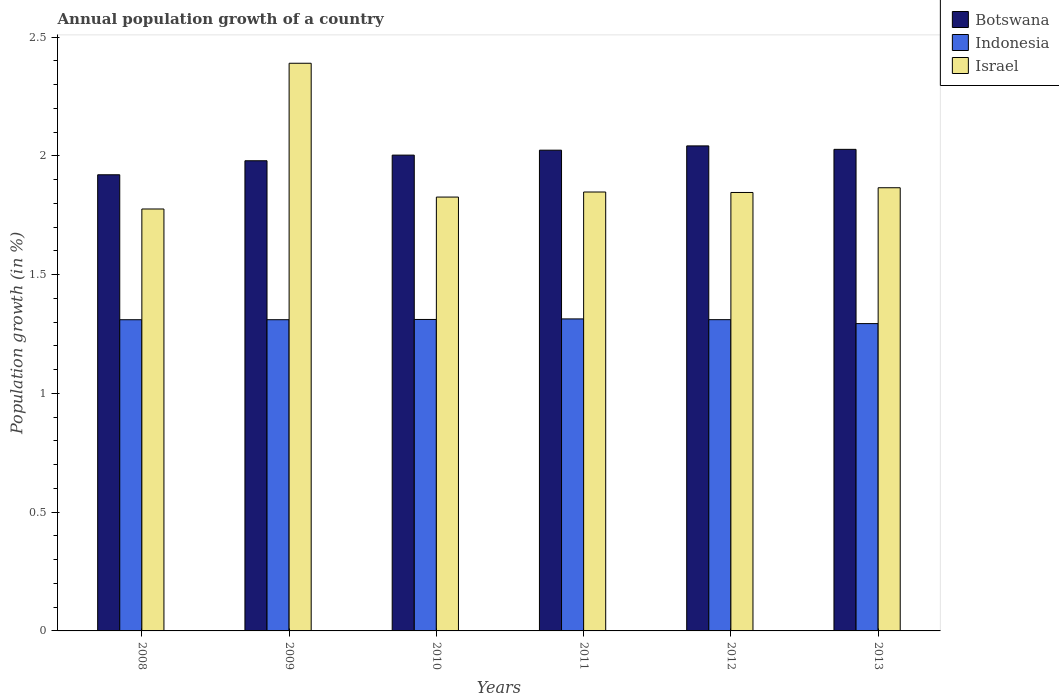How many groups of bars are there?
Your response must be concise. 6. Are the number of bars on each tick of the X-axis equal?
Ensure brevity in your answer.  Yes. How many bars are there on the 4th tick from the right?
Provide a succinct answer. 3. What is the label of the 2nd group of bars from the left?
Offer a terse response. 2009. In how many cases, is the number of bars for a given year not equal to the number of legend labels?
Keep it short and to the point. 0. What is the annual population growth in Israel in 2010?
Offer a very short reply. 1.83. Across all years, what is the maximum annual population growth in Indonesia?
Offer a very short reply. 1.31. Across all years, what is the minimum annual population growth in Israel?
Keep it short and to the point. 1.78. In which year was the annual population growth in Botswana maximum?
Provide a short and direct response. 2012. In which year was the annual population growth in Botswana minimum?
Your answer should be very brief. 2008. What is the total annual population growth in Indonesia in the graph?
Make the answer very short. 7.85. What is the difference between the annual population growth in Indonesia in 2009 and that in 2011?
Your answer should be very brief. -0. What is the difference between the annual population growth in Botswana in 2011 and the annual population growth in Indonesia in 2009?
Give a very brief answer. 0.71. What is the average annual population growth in Israel per year?
Give a very brief answer. 1.93. In the year 2013, what is the difference between the annual population growth in Botswana and annual population growth in Israel?
Provide a succinct answer. 0.16. In how many years, is the annual population growth in Botswana greater than 1.9 %?
Your answer should be very brief. 6. What is the ratio of the annual population growth in Indonesia in 2008 to that in 2012?
Provide a short and direct response. 1. Is the annual population growth in Israel in 2009 less than that in 2013?
Offer a terse response. No. Is the difference between the annual population growth in Botswana in 2008 and 2012 greater than the difference between the annual population growth in Israel in 2008 and 2012?
Give a very brief answer. No. What is the difference between the highest and the second highest annual population growth in Botswana?
Your response must be concise. 0.01. What is the difference between the highest and the lowest annual population growth in Israel?
Provide a succinct answer. 0.61. What does the 2nd bar from the left in 2010 represents?
Provide a succinct answer. Indonesia. What does the 2nd bar from the right in 2010 represents?
Your response must be concise. Indonesia. How many bars are there?
Your response must be concise. 18. Are all the bars in the graph horizontal?
Keep it short and to the point. No. How many years are there in the graph?
Provide a succinct answer. 6. Where does the legend appear in the graph?
Your answer should be compact. Top right. How many legend labels are there?
Your answer should be very brief. 3. What is the title of the graph?
Keep it short and to the point. Annual population growth of a country. Does "Moldova" appear as one of the legend labels in the graph?
Provide a succinct answer. No. What is the label or title of the X-axis?
Provide a short and direct response. Years. What is the label or title of the Y-axis?
Make the answer very short. Population growth (in %). What is the Population growth (in %) of Botswana in 2008?
Provide a short and direct response. 1.92. What is the Population growth (in %) in Indonesia in 2008?
Offer a very short reply. 1.31. What is the Population growth (in %) of Israel in 2008?
Give a very brief answer. 1.78. What is the Population growth (in %) in Botswana in 2009?
Your answer should be very brief. 1.98. What is the Population growth (in %) in Indonesia in 2009?
Provide a short and direct response. 1.31. What is the Population growth (in %) of Israel in 2009?
Make the answer very short. 2.39. What is the Population growth (in %) of Botswana in 2010?
Make the answer very short. 2. What is the Population growth (in %) of Indonesia in 2010?
Ensure brevity in your answer.  1.31. What is the Population growth (in %) of Israel in 2010?
Give a very brief answer. 1.83. What is the Population growth (in %) in Botswana in 2011?
Provide a short and direct response. 2.02. What is the Population growth (in %) of Indonesia in 2011?
Your answer should be very brief. 1.31. What is the Population growth (in %) in Israel in 2011?
Your answer should be very brief. 1.85. What is the Population growth (in %) in Botswana in 2012?
Offer a terse response. 2.04. What is the Population growth (in %) in Indonesia in 2012?
Keep it short and to the point. 1.31. What is the Population growth (in %) in Israel in 2012?
Ensure brevity in your answer.  1.85. What is the Population growth (in %) in Botswana in 2013?
Offer a very short reply. 2.03. What is the Population growth (in %) of Indonesia in 2013?
Keep it short and to the point. 1.29. What is the Population growth (in %) of Israel in 2013?
Offer a terse response. 1.87. Across all years, what is the maximum Population growth (in %) of Botswana?
Give a very brief answer. 2.04. Across all years, what is the maximum Population growth (in %) of Indonesia?
Your response must be concise. 1.31. Across all years, what is the maximum Population growth (in %) in Israel?
Give a very brief answer. 2.39. Across all years, what is the minimum Population growth (in %) of Botswana?
Your answer should be very brief. 1.92. Across all years, what is the minimum Population growth (in %) in Indonesia?
Your answer should be compact. 1.29. Across all years, what is the minimum Population growth (in %) of Israel?
Your response must be concise. 1.78. What is the total Population growth (in %) in Botswana in the graph?
Offer a terse response. 12. What is the total Population growth (in %) in Indonesia in the graph?
Your response must be concise. 7.85. What is the total Population growth (in %) of Israel in the graph?
Provide a short and direct response. 11.55. What is the difference between the Population growth (in %) in Botswana in 2008 and that in 2009?
Ensure brevity in your answer.  -0.06. What is the difference between the Population growth (in %) of Israel in 2008 and that in 2009?
Ensure brevity in your answer.  -0.61. What is the difference between the Population growth (in %) of Botswana in 2008 and that in 2010?
Your answer should be very brief. -0.08. What is the difference between the Population growth (in %) in Indonesia in 2008 and that in 2010?
Offer a terse response. -0. What is the difference between the Population growth (in %) in Israel in 2008 and that in 2010?
Your answer should be very brief. -0.05. What is the difference between the Population growth (in %) of Botswana in 2008 and that in 2011?
Your response must be concise. -0.1. What is the difference between the Population growth (in %) of Indonesia in 2008 and that in 2011?
Ensure brevity in your answer.  -0. What is the difference between the Population growth (in %) in Israel in 2008 and that in 2011?
Make the answer very short. -0.07. What is the difference between the Population growth (in %) of Botswana in 2008 and that in 2012?
Offer a terse response. -0.12. What is the difference between the Population growth (in %) in Indonesia in 2008 and that in 2012?
Ensure brevity in your answer.  -0. What is the difference between the Population growth (in %) in Israel in 2008 and that in 2012?
Keep it short and to the point. -0.07. What is the difference between the Population growth (in %) in Botswana in 2008 and that in 2013?
Provide a short and direct response. -0.11. What is the difference between the Population growth (in %) of Indonesia in 2008 and that in 2013?
Offer a terse response. 0.02. What is the difference between the Population growth (in %) in Israel in 2008 and that in 2013?
Make the answer very short. -0.09. What is the difference between the Population growth (in %) of Botswana in 2009 and that in 2010?
Provide a short and direct response. -0.02. What is the difference between the Population growth (in %) in Indonesia in 2009 and that in 2010?
Provide a succinct answer. -0. What is the difference between the Population growth (in %) in Israel in 2009 and that in 2010?
Keep it short and to the point. 0.56. What is the difference between the Population growth (in %) in Botswana in 2009 and that in 2011?
Provide a succinct answer. -0.04. What is the difference between the Population growth (in %) of Indonesia in 2009 and that in 2011?
Ensure brevity in your answer.  -0. What is the difference between the Population growth (in %) in Israel in 2009 and that in 2011?
Provide a succinct answer. 0.54. What is the difference between the Population growth (in %) of Botswana in 2009 and that in 2012?
Make the answer very short. -0.06. What is the difference between the Population growth (in %) in Indonesia in 2009 and that in 2012?
Your answer should be very brief. -0. What is the difference between the Population growth (in %) in Israel in 2009 and that in 2012?
Your answer should be very brief. 0.54. What is the difference between the Population growth (in %) of Botswana in 2009 and that in 2013?
Keep it short and to the point. -0.05. What is the difference between the Population growth (in %) of Indonesia in 2009 and that in 2013?
Provide a succinct answer. 0.02. What is the difference between the Population growth (in %) in Israel in 2009 and that in 2013?
Your response must be concise. 0.52. What is the difference between the Population growth (in %) in Botswana in 2010 and that in 2011?
Offer a very short reply. -0.02. What is the difference between the Population growth (in %) in Indonesia in 2010 and that in 2011?
Your response must be concise. -0. What is the difference between the Population growth (in %) in Israel in 2010 and that in 2011?
Make the answer very short. -0.02. What is the difference between the Population growth (in %) in Botswana in 2010 and that in 2012?
Offer a terse response. -0.04. What is the difference between the Population growth (in %) in Indonesia in 2010 and that in 2012?
Your answer should be very brief. 0. What is the difference between the Population growth (in %) in Israel in 2010 and that in 2012?
Your answer should be compact. -0.02. What is the difference between the Population growth (in %) in Botswana in 2010 and that in 2013?
Your answer should be very brief. -0.02. What is the difference between the Population growth (in %) in Indonesia in 2010 and that in 2013?
Provide a short and direct response. 0.02. What is the difference between the Population growth (in %) of Israel in 2010 and that in 2013?
Your answer should be very brief. -0.04. What is the difference between the Population growth (in %) of Botswana in 2011 and that in 2012?
Offer a terse response. -0.02. What is the difference between the Population growth (in %) in Indonesia in 2011 and that in 2012?
Make the answer very short. 0. What is the difference between the Population growth (in %) in Israel in 2011 and that in 2012?
Your answer should be very brief. 0. What is the difference between the Population growth (in %) in Botswana in 2011 and that in 2013?
Provide a short and direct response. -0. What is the difference between the Population growth (in %) of Indonesia in 2011 and that in 2013?
Give a very brief answer. 0.02. What is the difference between the Population growth (in %) of Israel in 2011 and that in 2013?
Offer a terse response. -0.02. What is the difference between the Population growth (in %) in Botswana in 2012 and that in 2013?
Your answer should be very brief. 0.01. What is the difference between the Population growth (in %) of Indonesia in 2012 and that in 2013?
Provide a short and direct response. 0.02. What is the difference between the Population growth (in %) of Israel in 2012 and that in 2013?
Ensure brevity in your answer.  -0.02. What is the difference between the Population growth (in %) of Botswana in 2008 and the Population growth (in %) of Indonesia in 2009?
Ensure brevity in your answer.  0.61. What is the difference between the Population growth (in %) of Botswana in 2008 and the Population growth (in %) of Israel in 2009?
Provide a short and direct response. -0.47. What is the difference between the Population growth (in %) of Indonesia in 2008 and the Population growth (in %) of Israel in 2009?
Your answer should be compact. -1.08. What is the difference between the Population growth (in %) in Botswana in 2008 and the Population growth (in %) in Indonesia in 2010?
Your response must be concise. 0.61. What is the difference between the Population growth (in %) in Botswana in 2008 and the Population growth (in %) in Israel in 2010?
Provide a succinct answer. 0.09. What is the difference between the Population growth (in %) of Indonesia in 2008 and the Population growth (in %) of Israel in 2010?
Your answer should be very brief. -0.52. What is the difference between the Population growth (in %) of Botswana in 2008 and the Population growth (in %) of Indonesia in 2011?
Keep it short and to the point. 0.61. What is the difference between the Population growth (in %) of Botswana in 2008 and the Population growth (in %) of Israel in 2011?
Offer a very short reply. 0.07. What is the difference between the Population growth (in %) of Indonesia in 2008 and the Population growth (in %) of Israel in 2011?
Your answer should be compact. -0.54. What is the difference between the Population growth (in %) of Botswana in 2008 and the Population growth (in %) of Indonesia in 2012?
Your answer should be compact. 0.61. What is the difference between the Population growth (in %) in Botswana in 2008 and the Population growth (in %) in Israel in 2012?
Offer a terse response. 0.07. What is the difference between the Population growth (in %) of Indonesia in 2008 and the Population growth (in %) of Israel in 2012?
Keep it short and to the point. -0.54. What is the difference between the Population growth (in %) of Botswana in 2008 and the Population growth (in %) of Indonesia in 2013?
Your response must be concise. 0.63. What is the difference between the Population growth (in %) of Botswana in 2008 and the Population growth (in %) of Israel in 2013?
Offer a terse response. 0.05. What is the difference between the Population growth (in %) of Indonesia in 2008 and the Population growth (in %) of Israel in 2013?
Your answer should be very brief. -0.56. What is the difference between the Population growth (in %) in Botswana in 2009 and the Population growth (in %) in Indonesia in 2010?
Provide a succinct answer. 0.67. What is the difference between the Population growth (in %) in Botswana in 2009 and the Population growth (in %) in Israel in 2010?
Ensure brevity in your answer.  0.15. What is the difference between the Population growth (in %) in Indonesia in 2009 and the Population growth (in %) in Israel in 2010?
Give a very brief answer. -0.52. What is the difference between the Population growth (in %) of Botswana in 2009 and the Population growth (in %) of Indonesia in 2011?
Your answer should be very brief. 0.67. What is the difference between the Population growth (in %) of Botswana in 2009 and the Population growth (in %) of Israel in 2011?
Provide a succinct answer. 0.13. What is the difference between the Population growth (in %) in Indonesia in 2009 and the Population growth (in %) in Israel in 2011?
Provide a short and direct response. -0.54. What is the difference between the Population growth (in %) of Botswana in 2009 and the Population growth (in %) of Indonesia in 2012?
Your answer should be compact. 0.67. What is the difference between the Population growth (in %) of Botswana in 2009 and the Population growth (in %) of Israel in 2012?
Your response must be concise. 0.13. What is the difference between the Population growth (in %) in Indonesia in 2009 and the Population growth (in %) in Israel in 2012?
Provide a short and direct response. -0.54. What is the difference between the Population growth (in %) of Botswana in 2009 and the Population growth (in %) of Indonesia in 2013?
Your response must be concise. 0.69. What is the difference between the Population growth (in %) in Botswana in 2009 and the Population growth (in %) in Israel in 2013?
Provide a short and direct response. 0.11. What is the difference between the Population growth (in %) in Indonesia in 2009 and the Population growth (in %) in Israel in 2013?
Your answer should be very brief. -0.56. What is the difference between the Population growth (in %) in Botswana in 2010 and the Population growth (in %) in Indonesia in 2011?
Your answer should be compact. 0.69. What is the difference between the Population growth (in %) of Botswana in 2010 and the Population growth (in %) of Israel in 2011?
Make the answer very short. 0.16. What is the difference between the Population growth (in %) in Indonesia in 2010 and the Population growth (in %) in Israel in 2011?
Provide a succinct answer. -0.54. What is the difference between the Population growth (in %) in Botswana in 2010 and the Population growth (in %) in Indonesia in 2012?
Offer a very short reply. 0.69. What is the difference between the Population growth (in %) in Botswana in 2010 and the Population growth (in %) in Israel in 2012?
Give a very brief answer. 0.16. What is the difference between the Population growth (in %) of Indonesia in 2010 and the Population growth (in %) of Israel in 2012?
Offer a very short reply. -0.53. What is the difference between the Population growth (in %) of Botswana in 2010 and the Population growth (in %) of Indonesia in 2013?
Provide a succinct answer. 0.71. What is the difference between the Population growth (in %) in Botswana in 2010 and the Population growth (in %) in Israel in 2013?
Offer a terse response. 0.14. What is the difference between the Population growth (in %) in Indonesia in 2010 and the Population growth (in %) in Israel in 2013?
Your response must be concise. -0.55. What is the difference between the Population growth (in %) in Botswana in 2011 and the Population growth (in %) in Indonesia in 2012?
Your answer should be compact. 0.71. What is the difference between the Population growth (in %) in Botswana in 2011 and the Population growth (in %) in Israel in 2012?
Your response must be concise. 0.18. What is the difference between the Population growth (in %) in Indonesia in 2011 and the Population growth (in %) in Israel in 2012?
Your answer should be very brief. -0.53. What is the difference between the Population growth (in %) in Botswana in 2011 and the Population growth (in %) in Indonesia in 2013?
Offer a very short reply. 0.73. What is the difference between the Population growth (in %) in Botswana in 2011 and the Population growth (in %) in Israel in 2013?
Ensure brevity in your answer.  0.16. What is the difference between the Population growth (in %) of Indonesia in 2011 and the Population growth (in %) of Israel in 2013?
Give a very brief answer. -0.55. What is the difference between the Population growth (in %) of Botswana in 2012 and the Population growth (in %) of Indonesia in 2013?
Provide a short and direct response. 0.75. What is the difference between the Population growth (in %) in Botswana in 2012 and the Population growth (in %) in Israel in 2013?
Your answer should be compact. 0.18. What is the difference between the Population growth (in %) in Indonesia in 2012 and the Population growth (in %) in Israel in 2013?
Provide a short and direct response. -0.56. What is the average Population growth (in %) of Botswana per year?
Offer a very short reply. 2. What is the average Population growth (in %) in Indonesia per year?
Provide a short and direct response. 1.31. What is the average Population growth (in %) of Israel per year?
Offer a very short reply. 1.93. In the year 2008, what is the difference between the Population growth (in %) of Botswana and Population growth (in %) of Indonesia?
Offer a very short reply. 0.61. In the year 2008, what is the difference between the Population growth (in %) of Botswana and Population growth (in %) of Israel?
Your answer should be compact. 0.14. In the year 2008, what is the difference between the Population growth (in %) in Indonesia and Population growth (in %) in Israel?
Provide a short and direct response. -0.47. In the year 2009, what is the difference between the Population growth (in %) of Botswana and Population growth (in %) of Indonesia?
Keep it short and to the point. 0.67. In the year 2009, what is the difference between the Population growth (in %) of Botswana and Population growth (in %) of Israel?
Provide a short and direct response. -0.41. In the year 2009, what is the difference between the Population growth (in %) of Indonesia and Population growth (in %) of Israel?
Your response must be concise. -1.08. In the year 2010, what is the difference between the Population growth (in %) of Botswana and Population growth (in %) of Indonesia?
Ensure brevity in your answer.  0.69. In the year 2010, what is the difference between the Population growth (in %) in Botswana and Population growth (in %) in Israel?
Provide a succinct answer. 0.18. In the year 2010, what is the difference between the Population growth (in %) of Indonesia and Population growth (in %) of Israel?
Your answer should be compact. -0.52. In the year 2011, what is the difference between the Population growth (in %) of Botswana and Population growth (in %) of Indonesia?
Ensure brevity in your answer.  0.71. In the year 2011, what is the difference between the Population growth (in %) of Botswana and Population growth (in %) of Israel?
Provide a succinct answer. 0.18. In the year 2011, what is the difference between the Population growth (in %) of Indonesia and Population growth (in %) of Israel?
Make the answer very short. -0.53. In the year 2012, what is the difference between the Population growth (in %) in Botswana and Population growth (in %) in Indonesia?
Keep it short and to the point. 0.73. In the year 2012, what is the difference between the Population growth (in %) in Botswana and Population growth (in %) in Israel?
Keep it short and to the point. 0.2. In the year 2012, what is the difference between the Population growth (in %) of Indonesia and Population growth (in %) of Israel?
Your answer should be very brief. -0.54. In the year 2013, what is the difference between the Population growth (in %) in Botswana and Population growth (in %) in Indonesia?
Ensure brevity in your answer.  0.73. In the year 2013, what is the difference between the Population growth (in %) of Botswana and Population growth (in %) of Israel?
Give a very brief answer. 0.16. In the year 2013, what is the difference between the Population growth (in %) in Indonesia and Population growth (in %) in Israel?
Provide a short and direct response. -0.57. What is the ratio of the Population growth (in %) in Botswana in 2008 to that in 2009?
Provide a succinct answer. 0.97. What is the ratio of the Population growth (in %) in Israel in 2008 to that in 2009?
Keep it short and to the point. 0.74. What is the ratio of the Population growth (in %) in Botswana in 2008 to that in 2010?
Make the answer very short. 0.96. What is the ratio of the Population growth (in %) of Indonesia in 2008 to that in 2010?
Keep it short and to the point. 1. What is the ratio of the Population growth (in %) in Israel in 2008 to that in 2010?
Offer a very short reply. 0.97. What is the ratio of the Population growth (in %) in Botswana in 2008 to that in 2011?
Provide a succinct answer. 0.95. What is the ratio of the Population growth (in %) in Israel in 2008 to that in 2011?
Your answer should be compact. 0.96. What is the ratio of the Population growth (in %) of Botswana in 2008 to that in 2012?
Give a very brief answer. 0.94. What is the ratio of the Population growth (in %) in Israel in 2008 to that in 2012?
Provide a succinct answer. 0.96. What is the ratio of the Population growth (in %) in Botswana in 2008 to that in 2013?
Ensure brevity in your answer.  0.95. What is the ratio of the Population growth (in %) of Indonesia in 2008 to that in 2013?
Give a very brief answer. 1.01. What is the ratio of the Population growth (in %) in Israel in 2008 to that in 2013?
Keep it short and to the point. 0.95. What is the ratio of the Population growth (in %) of Indonesia in 2009 to that in 2010?
Provide a short and direct response. 1. What is the ratio of the Population growth (in %) of Israel in 2009 to that in 2010?
Ensure brevity in your answer.  1.31. What is the ratio of the Population growth (in %) in Botswana in 2009 to that in 2011?
Ensure brevity in your answer.  0.98. What is the ratio of the Population growth (in %) in Israel in 2009 to that in 2011?
Give a very brief answer. 1.29. What is the ratio of the Population growth (in %) in Botswana in 2009 to that in 2012?
Your response must be concise. 0.97. What is the ratio of the Population growth (in %) in Indonesia in 2009 to that in 2012?
Your answer should be very brief. 1. What is the ratio of the Population growth (in %) of Israel in 2009 to that in 2012?
Offer a terse response. 1.29. What is the ratio of the Population growth (in %) in Botswana in 2009 to that in 2013?
Make the answer very short. 0.98. What is the ratio of the Population growth (in %) of Indonesia in 2009 to that in 2013?
Give a very brief answer. 1.01. What is the ratio of the Population growth (in %) of Israel in 2009 to that in 2013?
Make the answer very short. 1.28. What is the ratio of the Population growth (in %) in Indonesia in 2010 to that in 2011?
Ensure brevity in your answer.  1. What is the ratio of the Population growth (in %) of Indonesia in 2010 to that in 2012?
Provide a succinct answer. 1. What is the ratio of the Population growth (in %) in Israel in 2010 to that in 2012?
Offer a very short reply. 0.99. What is the ratio of the Population growth (in %) of Indonesia in 2010 to that in 2013?
Keep it short and to the point. 1.01. What is the ratio of the Population growth (in %) in Israel in 2010 to that in 2013?
Keep it short and to the point. 0.98. What is the ratio of the Population growth (in %) of Indonesia in 2011 to that in 2012?
Offer a very short reply. 1. What is the ratio of the Population growth (in %) in Israel in 2011 to that in 2012?
Offer a very short reply. 1. What is the ratio of the Population growth (in %) of Indonesia in 2011 to that in 2013?
Provide a succinct answer. 1.02. What is the ratio of the Population growth (in %) of Israel in 2011 to that in 2013?
Offer a very short reply. 0.99. What is the ratio of the Population growth (in %) of Indonesia in 2012 to that in 2013?
Offer a very short reply. 1.01. What is the ratio of the Population growth (in %) of Israel in 2012 to that in 2013?
Offer a very short reply. 0.99. What is the difference between the highest and the second highest Population growth (in %) in Botswana?
Your answer should be very brief. 0.01. What is the difference between the highest and the second highest Population growth (in %) of Indonesia?
Give a very brief answer. 0. What is the difference between the highest and the second highest Population growth (in %) of Israel?
Give a very brief answer. 0.52. What is the difference between the highest and the lowest Population growth (in %) of Botswana?
Your answer should be compact. 0.12. What is the difference between the highest and the lowest Population growth (in %) in Indonesia?
Keep it short and to the point. 0.02. What is the difference between the highest and the lowest Population growth (in %) in Israel?
Offer a terse response. 0.61. 